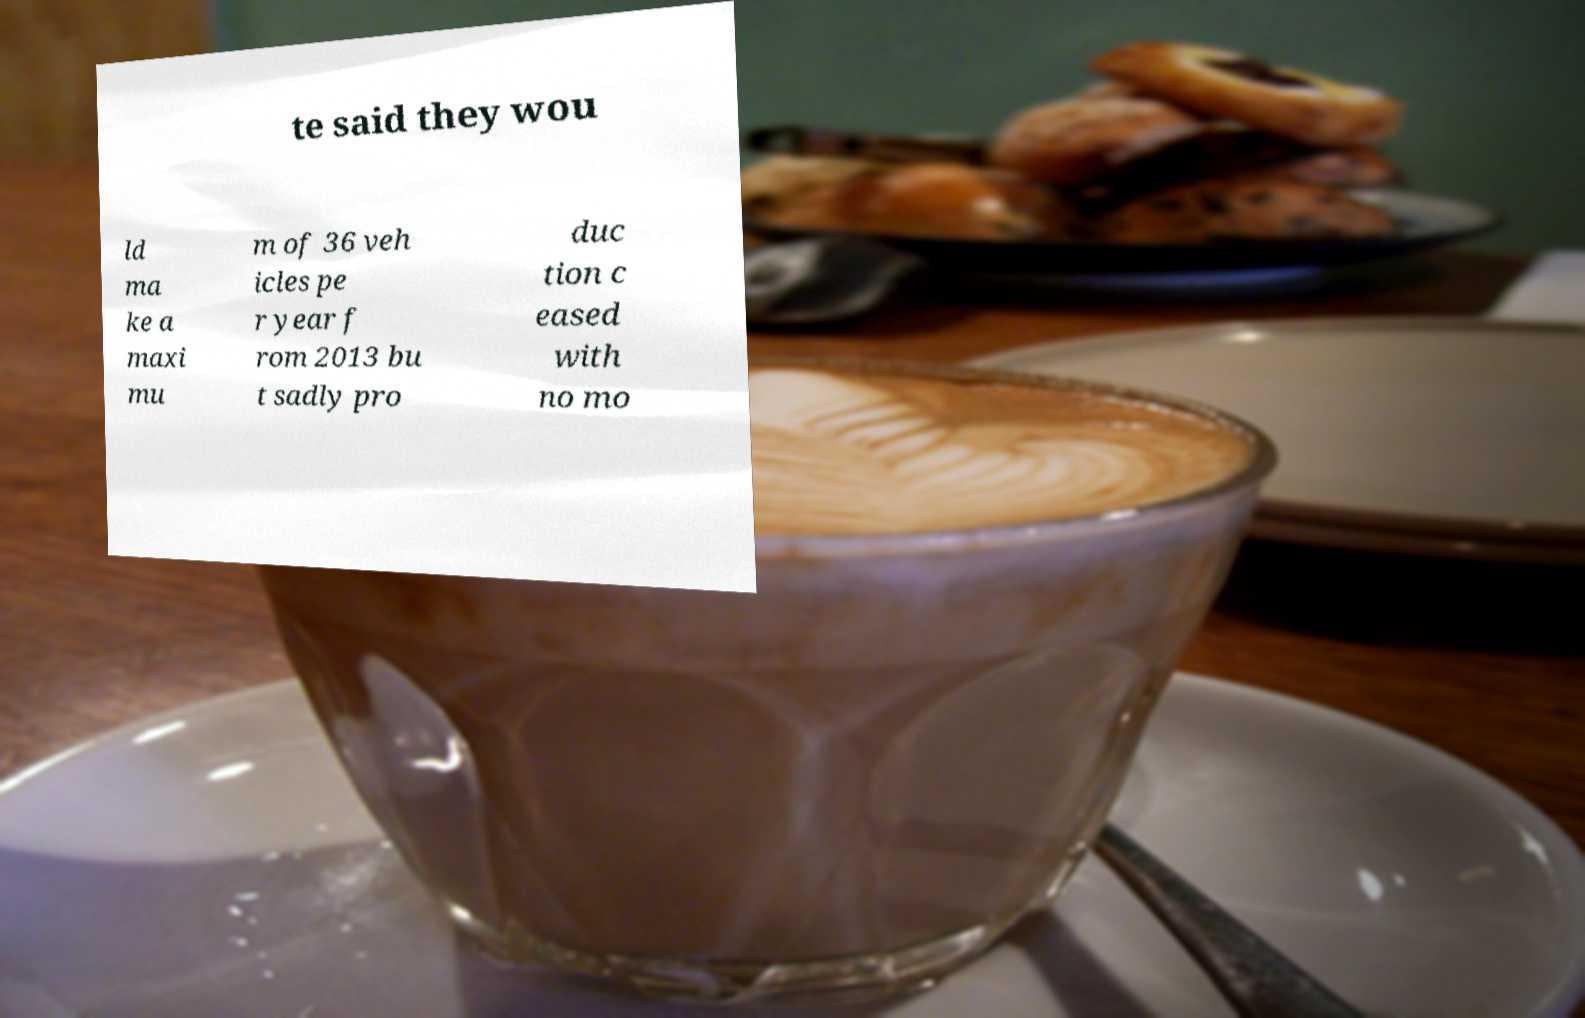Could you assist in decoding the text presented in this image and type it out clearly? te said they wou ld ma ke a maxi mu m of 36 veh icles pe r year f rom 2013 bu t sadly pro duc tion c eased with no mo 